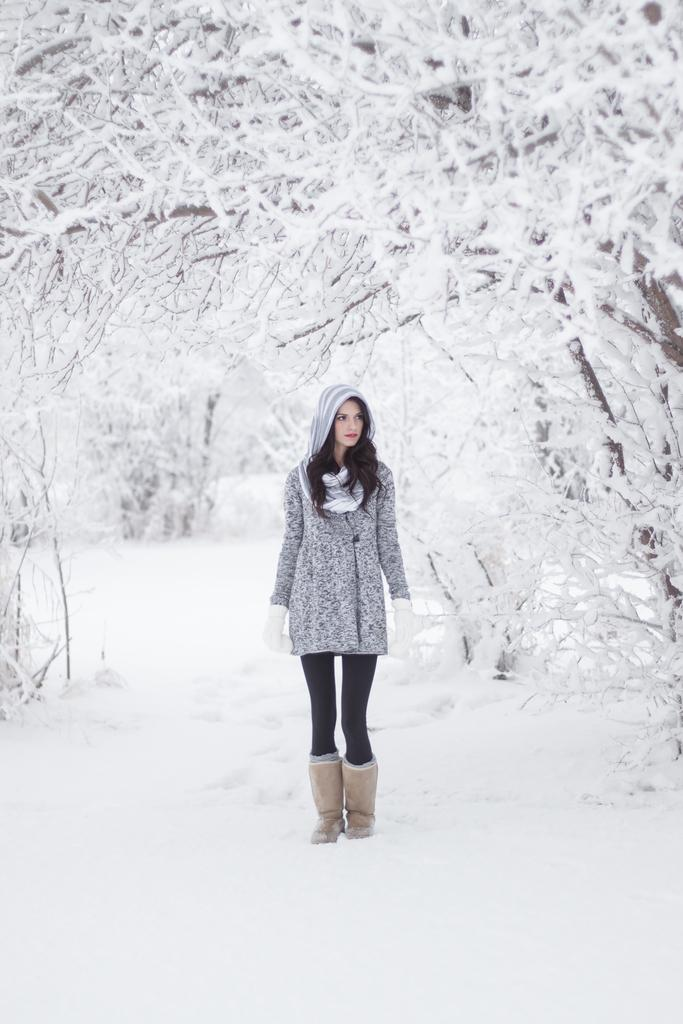What is the woman standing on in the image? The woman is standing in the snow. What other elements can be seen in the image besides the woman? There are a few trees in the image. How are the trees affected by the snow? The trees are covered with snow. What type of tank can be seen in the image? There is no tank present in the image. How does the snow affect the acoustics in the image? There is no information provided about the acoustics in the image. 